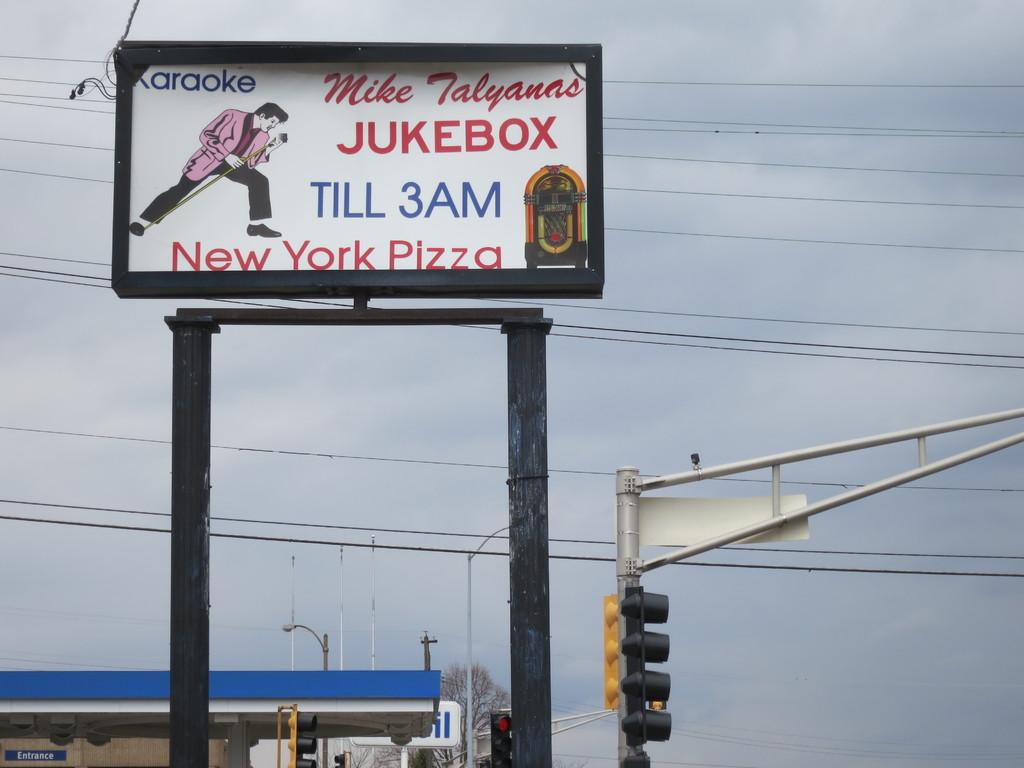Provide a one-sentence caption for the provided image. A billboard for the Mike Talyanas Jukebox offering Karaoke and New York Pizza. 